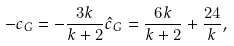Convert formula to latex. <formula><loc_0><loc_0><loc_500><loc_500>- c _ { G } = - \frac { 3 k } { k + 2 } \hat { c } _ { G } = \frac { 6 k } { k + 2 } + \frac { 2 4 } { k } ,</formula> 